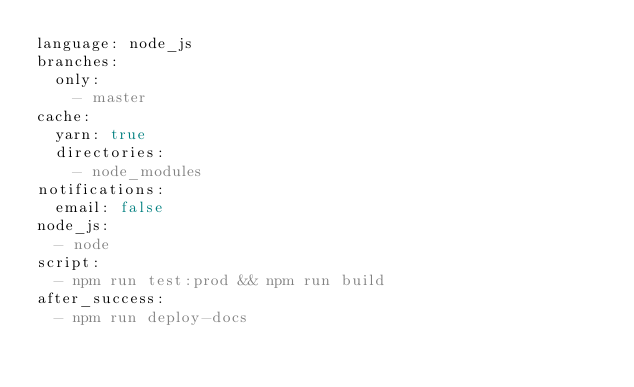<code> <loc_0><loc_0><loc_500><loc_500><_YAML_>language: node_js
branches:
  only:
    - master
cache:
  yarn: true
  directories:
    - node_modules
notifications:
  email: false
node_js:
  - node
script:
  - npm run test:prod && npm run build
after_success:
  - npm run deploy-docs
</code> 